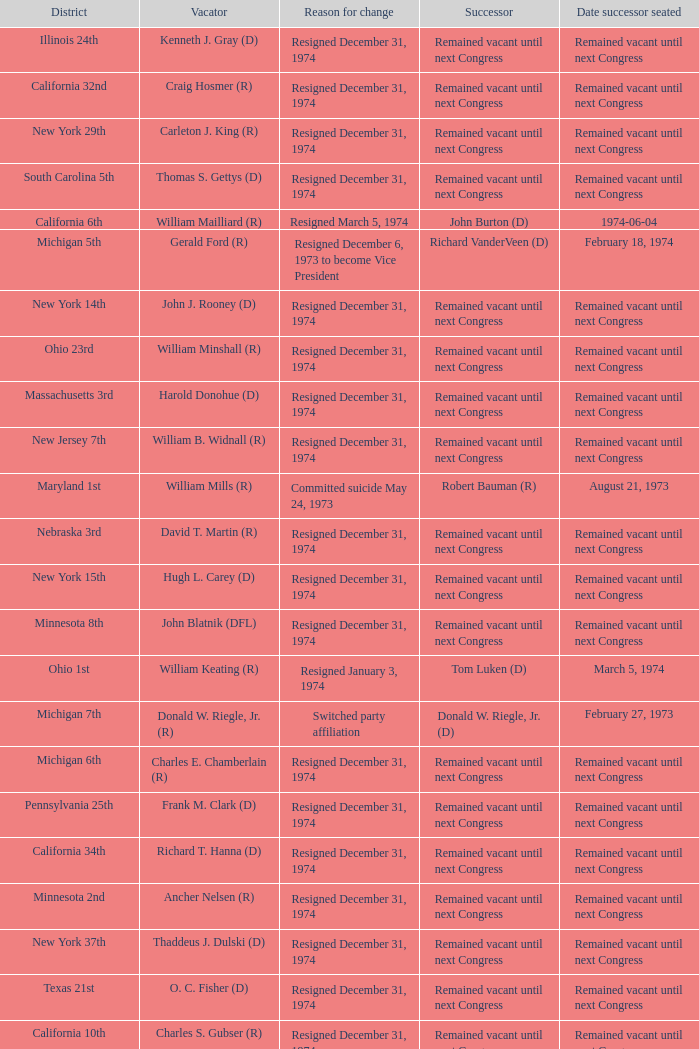I'm looking to parse the entire table for insights. Could you assist me with that? {'header': ['District', 'Vacator', 'Reason for change', 'Successor', 'Date successor seated'], 'rows': [['Illinois 24th', 'Kenneth J. Gray (D)', 'Resigned December 31, 1974', 'Remained vacant until next Congress', 'Remained vacant until next Congress'], ['California 32nd', 'Craig Hosmer (R)', 'Resigned December 31, 1974', 'Remained vacant until next Congress', 'Remained vacant until next Congress'], ['New York 29th', 'Carleton J. King (R)', 'Resigned December 31, 1974', 'Remained vacant until next Congress', 'Remained vacant until next Congress'], ['South Carolina 5th', 'Thomas S. Gettys (D)', 'Resigned December 31, 1974', 'Remained vacant until next Congress', 'Remained vacant until next Congress'], ['California 6th', 'William Mailliard (R)', 'Resigned March 5, 1974', 'John Burton (D)', '1974-06-04'], ['Michigan 5th', 'Gerald Ford (R)', 'Resigned December 6, 1973 to become Vice President', 'Richard VanderVeen (D)', 'February 18, 1974'], ['New York 14th', 'John J. Rooney (D)', 'Resigned December 31, 1974', 'Remained vacant until next Congress', 'Remained vacant until next Congress'], ['Ohio 23rd', 'William Minshall (R)', 'Resigned December 31, 1974', 'Remained vacant until next Congress', 'Remained vacant until next Congress'], ['Massachusetts 3rd', 'Harold Donohue (D)', 'Resigned December 31, 1974', 'Remained vacant until next Congress', 'Remained vacant until next Congress'], ['New Jersey 7th', 'William B. Widnall (R)', 'Resigned December 31, 1974', 'Remained vacant until next Congress', 'Remained vacant until next Congress'], ['Maryland 1st', 'William Mills (R)', 'Committed suicide May 24, 1973', 'Robert Bauman (R)', 'August 21, 1973'], ['Nebraska 3rd', 'David T. Martin (R)', 'Resigned December 31, 1974', 'Remained vacant until next Congress', 'Remained vacant until next Congress'], ['New York 15th', 'Hugh L. Carey (D)', 'Resigned December 31, 1974', 'Remained vacant until next Congress', 'Remained vacant until next Congress'], ['Minnesota 8th', 'John Blatnik (DFL)', 'Resigned December 31, 1974', 'Remained vacant until next Congress', 'Remained vacant until next Congress'], ['Ohio 1st', 'William Keating (R)', 'Resigned January 3, 1974', 'Tom Luken (D)', 'March 5, 1974'], ['Michigan 7th', 'Donald W. Riegle, Jr. (R)', 'Switched party affiliation', 'Donald W. Riegle, Jr. (D)', 'February 27, 1973'], ['Michigan 6th', 'Charles E. Chamberlain (R)', 'Resigned December 31, 1974', 'Remained vacant until next Congress', 'Remained vacant until next Congress'], ['Pennsylvania 25th', 'Frank M. Clark (D)', 'Resigned December 31, 1974', 'Remained vacant until next Congress', 'Remained vacant until next Congress'], ['California 34th', 'Richard T. Hanna (D)', 'Resigned December 31, 1974', 'Remained vacant until next Congress', 'Remained vacant until next Congress'], ['Minnesota 2nd', 'Ancher Nelsen (R)', 'Resigned December 31, 1974', 'Remained vacant until next Congress', 'Remained vacant until next Congress'], ['New York 37th', 'Thaddeus J. Dulski (D)', 'Resigned December 31, 1974', 'Remained vacant until next Congress', 'Remained vacant until next Congress'], ['Texas 21st', 'O. C. Fisher (D)', 'Resigned December 31, 1974', 'Remained vacant until next Congress', 'Remained vacant until next Congress'], ['California 10th', 'Charles S. Gubser (R)', 'Resigned December 31, 1974', 'Remained vacant until next Congress', 'Remained vacant until next Congress'], ['Washington 3rd', 'Julia B. Hansen (D)', 'Resigned December 31, 1974', 'Remained vacant until next Congress', 'Remained vacant until next Congress'], ['California 13th', 'Charles Teague (R)', 'Died January 1, 1974', 'Robert Lagomarsino (R)', '1974-03-05'], ['Michigan 17th', 'Martha Griffiths (D)', 'Resigned December 31, 1974', 'Remained vacant until next Congress', 'Remained vacant until next Congress'], ['California 19th', 'Chester E. Holifield (D)', 'Resigned December 31, 1974', 'Remained vacant until next Congress', 'Remained vacant until next Congress'], ['Oregon 3rd', 'Edith S. Green (D)', 'Resigned December 31, 1974', 'Remained vacant until next Congress', 'Remained vacant until next Congress'], ['South Carolina 3rd', 'W.J. Bryan Dorn (D)', 'Resigned December 31, 1974', 'Remained vacant until next Congress', 'Remained vacant until next Congress'], ['Wisconsin 3rd', 'Vernon W. Thomson (R)', 'Resigned December 31, 1974', 'Remained vacant until next Congress', 'Remained vacant until next Congress'], ['Kentucky 1st', 'Frank Stubblefield (D)', 'Resigned December 31, 1974', 'Remained vacant until next Congress', 'Remained vacant until next Congress'], ['Pennsylvania 12th', 'John Saylor (R)', 'Died October 28, 1973', 'John Murtha (D)', 'February 5, 1974']]} Who was the successor when the vacator was chester e. holifield (d)? Remained vacant until next Congress. 